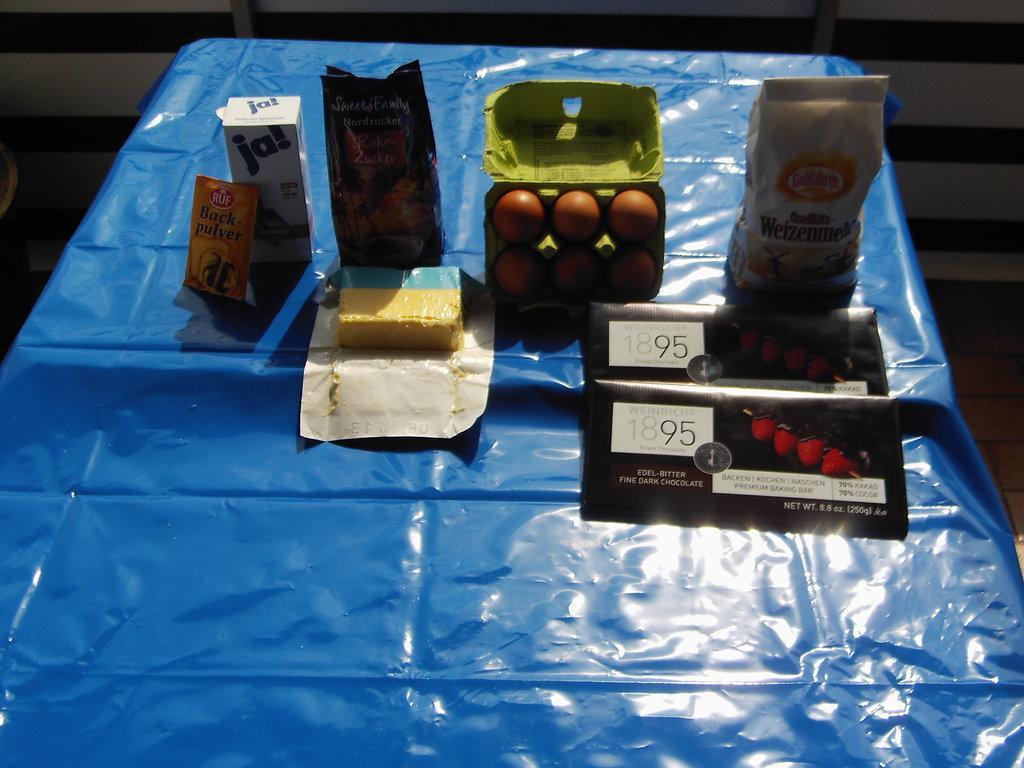How would you summarize this image in a sentence or two? In this picture I can observe eggs and some food packets placed on the table. There is a blue color cover on the table. 